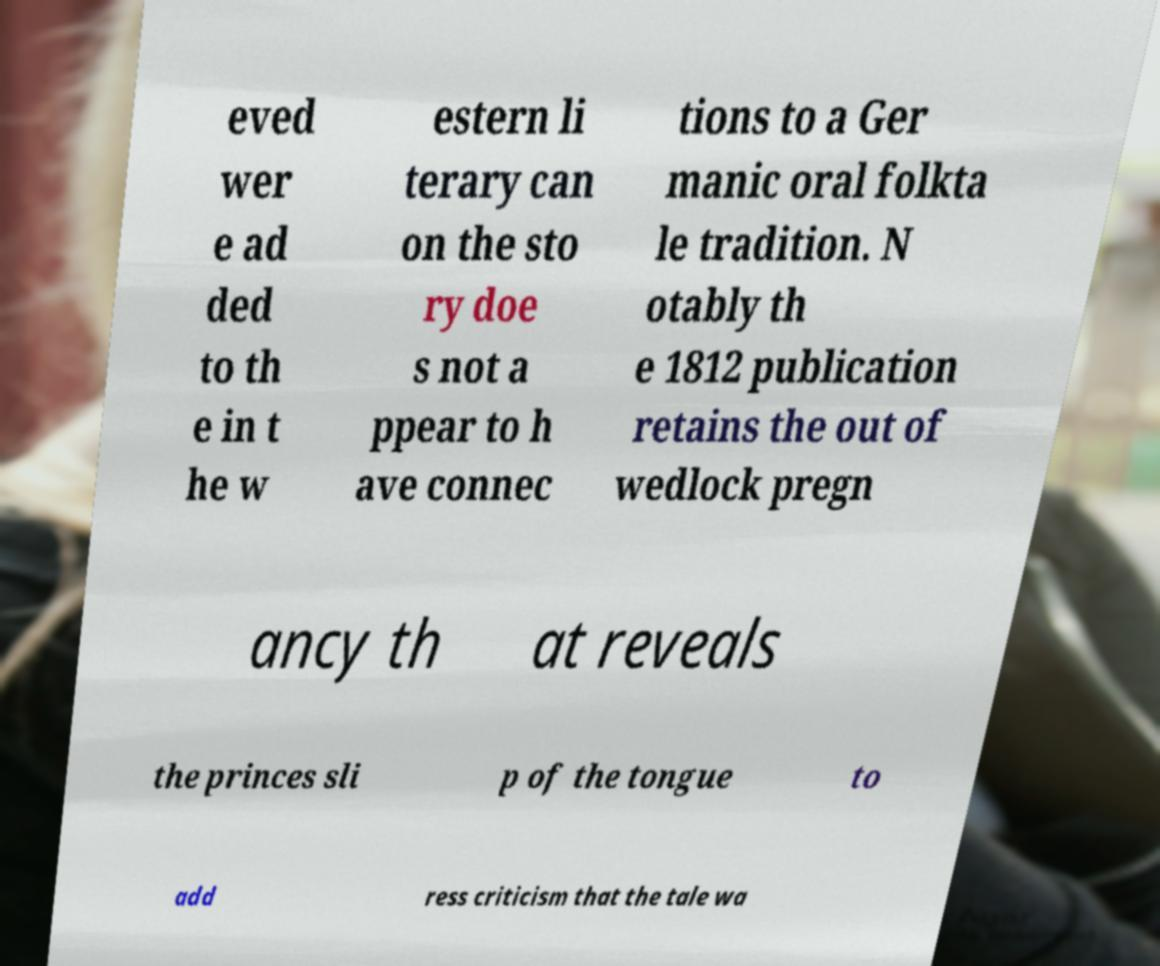I need the written content from this picture converted into text. Can you do that? eved wer e ad ded to th e in t he w estern li terary can on the sto ry doe s not a ppear to h ave connec tions to a Ger manic oral folkta le tradition. N otably th e 1812 publication retains the out of wedlock pregn ancy th at reveals the princes sli p of the tongue to add ress criticism that the tale wa 